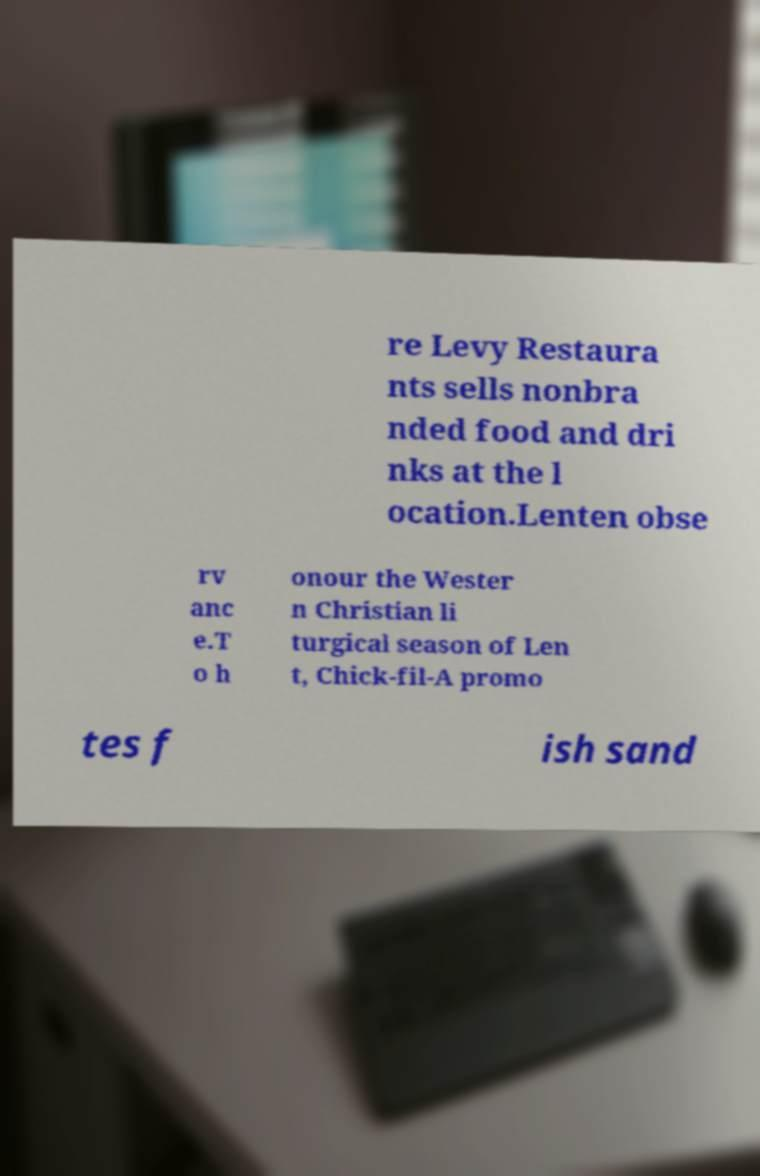Can you read and provide the text displayed in the image?This photo seems to have some interesting text. Can you extract and type it out for me? re Levy Restaura nts sells nonbra nded food and dri nks at the l ocation.Lenten obse rv anc e.T o h onour the Wester n Christian li turgical season of Len t, Chick-fil-A promo tes f ish sand 